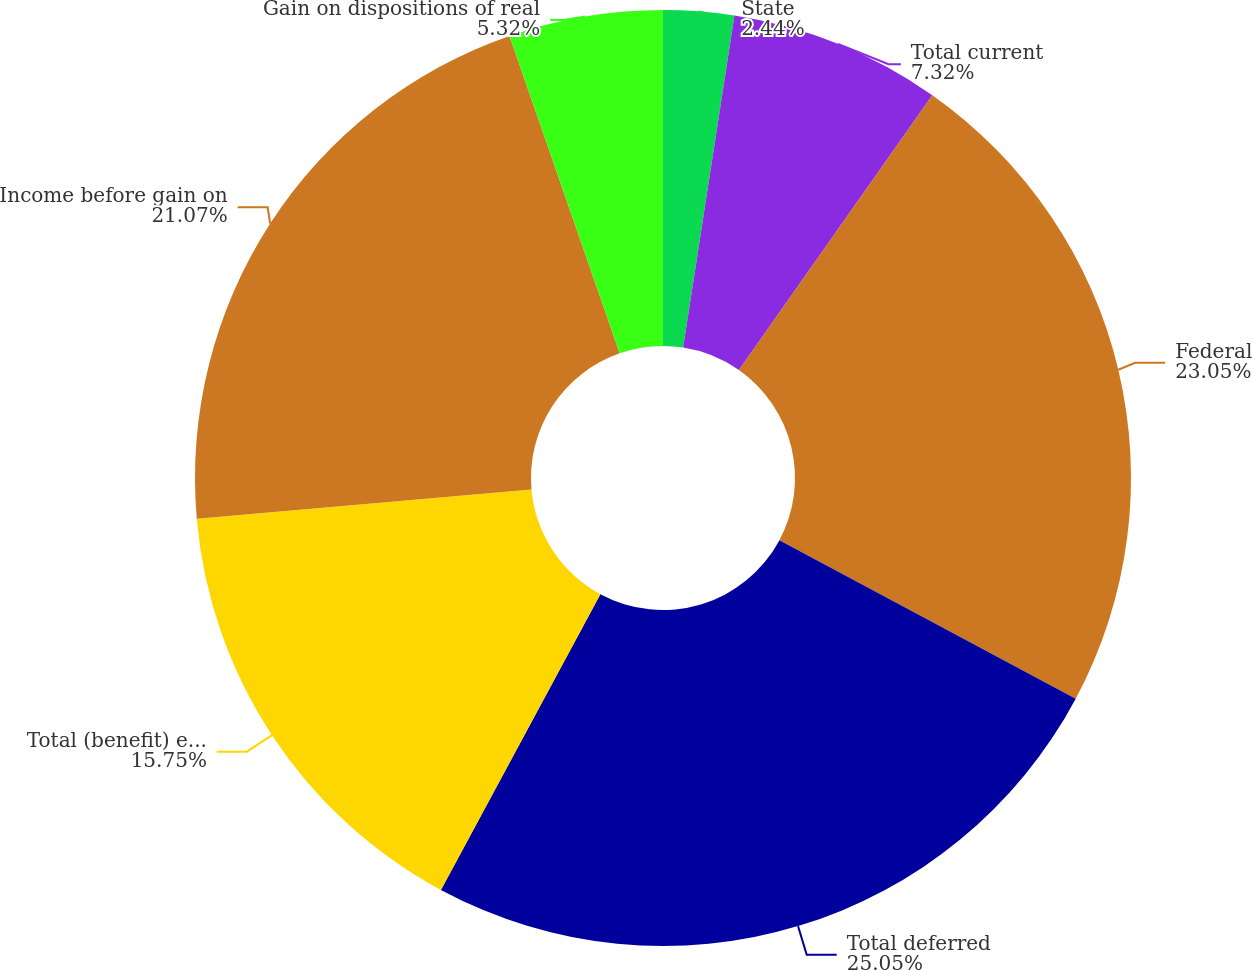<chart> <loc_0><loc_0><loc_500><loc_500><pie_chart><fcel>State<fcel>Total current<fcel>Federal<fcel>Total deferred<fcel>Total (benefit) expense<fcel>Income before gain on<fcel>Gain on dispositions of real<nl><fcel>2.44%<fcel>7.32%<fcel>23.06%<fcel>25.06%<fcel>15.75%<fcel>21.07%<fcel>5.32%<nl></chart> 